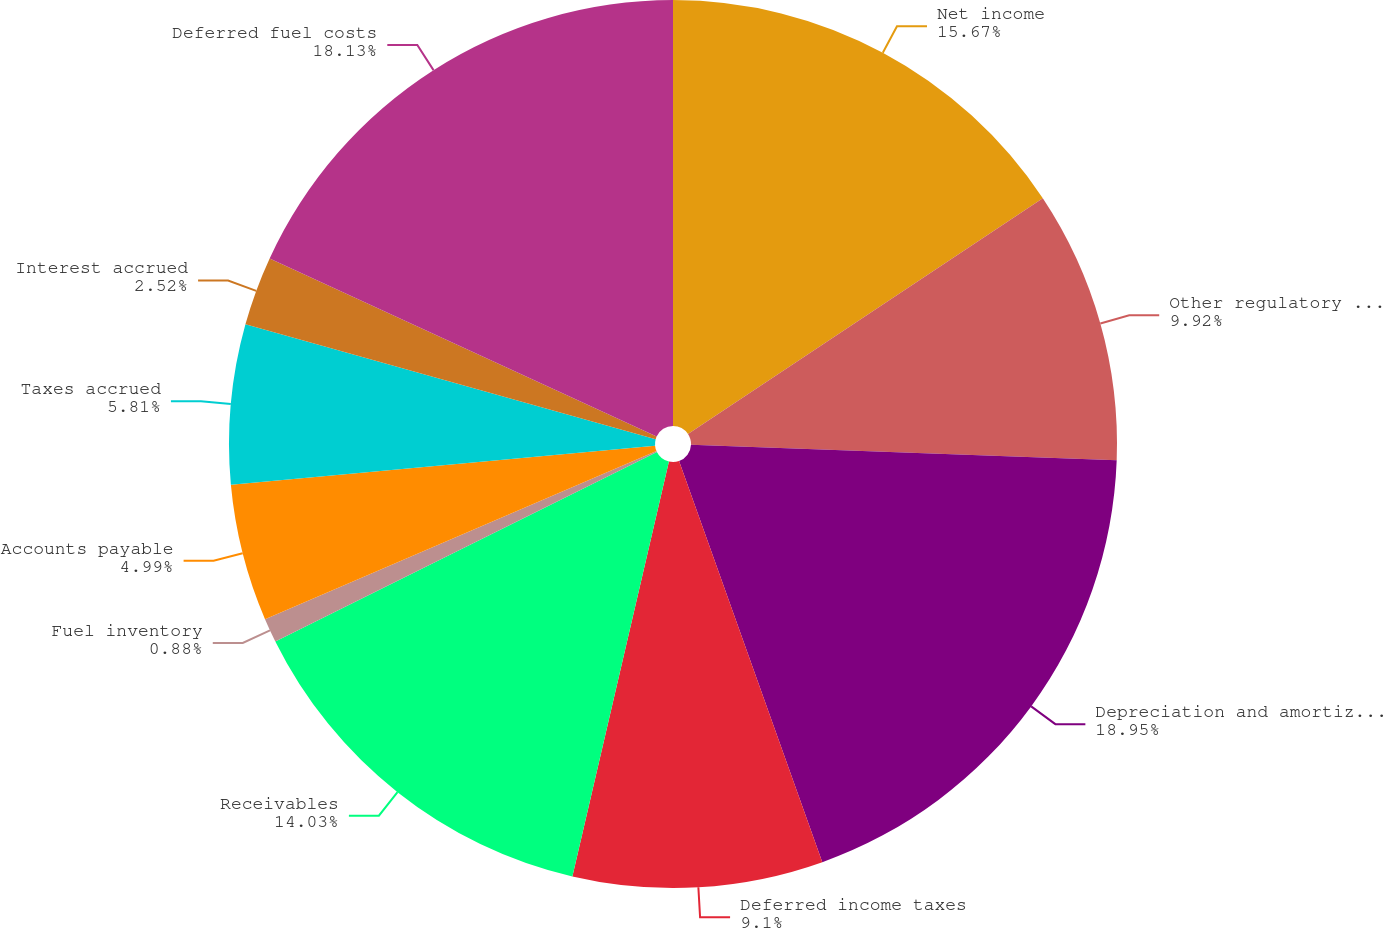Convert chart. <chart><loc_0><loc_0><loc_500><loc_500><pie_chart><fcel>Net income<fcel>Other regulatory charges<fcel>Depreciation and amortization<fcel>Deferred income taxes<fcel>Receivables<fcel>Fuel inventory<fcel>Accounts payable<fcel>Taxes accrued<fcel>Interest accrued<fcel>Deferred fuel costs<nl><fcel>15.67%<fcel>9.92%<fcel>18.96%<fcel>9.1%<fcel>14.03%<fcel>0.88%<fcel>4.99%<fcel>5.81%<fcel>2.52%<fcel>18.14%<nl></chart> 